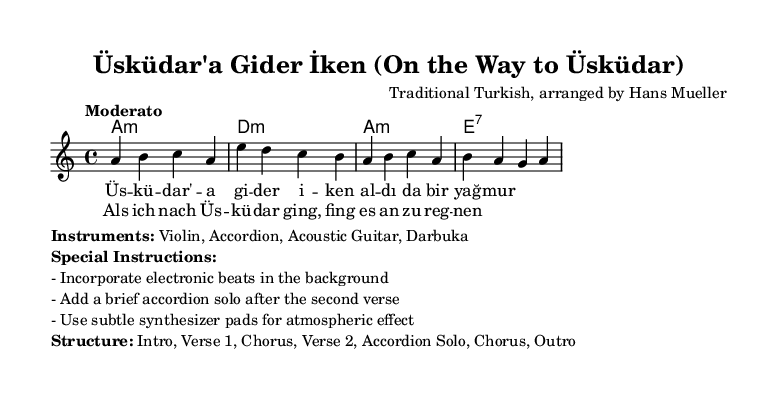What is the key signature of this music? The key signature is A minor, indicated by the presence of one sharp (G#) in its scale. A minor is the relative minor of C major, which contains no sharps or flats.
Answer: A minor What is the time signature of the piece? The time signature is displayed as 4/4, meaning there are four beats per measure and the quarter note receives one beat. This is a common time signature in many musical genres.
Answer: 4/4 Who is the composer of this arrangement? The composer is noted as "Traditional Turkish, arranged by Hans Mueller," indicating that the melody is based on traditional Turkish folklore, but has been arranged by Hans Mueller for a modern interpretation.
Answer: Hans Mueller What instruments are included in the performance? The instruments listed are Violin, Accordion, Acoustic Guitar, and Darbuka. This combination highlights traditional Turkish sounds blended with contemporary styles.
Answer: Violin, Accordion, Acoustic Guitar, Darbuka What is the tempo marking for the piece? The tempo marking is "Moderato," suggesting that the piece should be played at a moderate speed, which is typically a lively but not too fast pace.
Answer: Moderato How many verses are included in the structure? The structure includes two verses as indicated in the score, leading to an accordion solo before repeating the chorus. This is a common structure in folk music, allowing for storytelling through verses.
Answer: Two 